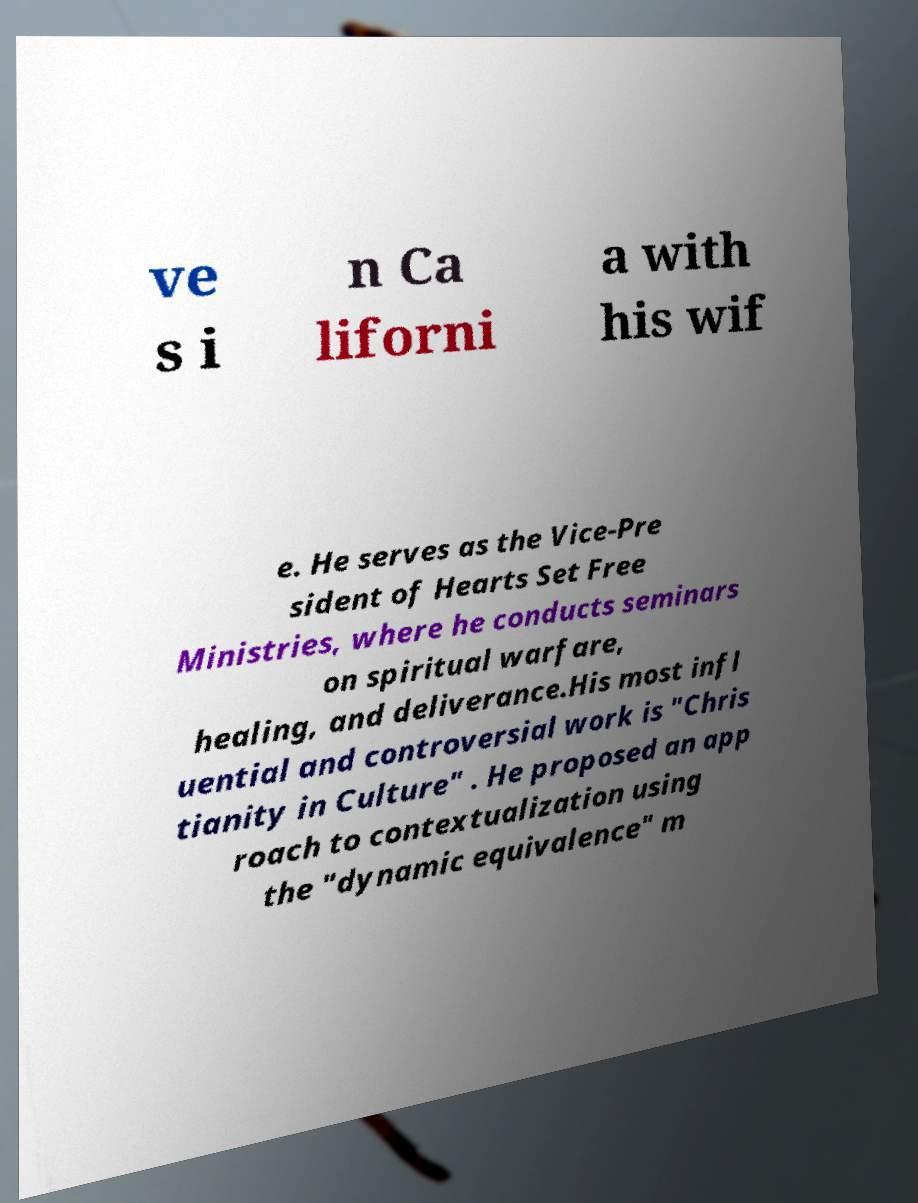Please identify and transcribe the text found in this image. ve s i n Ca liforni a with his wif e. He serves as the Vice-Pre sident of Hearts Set Free Ministries, where he conducts seminars on spiritual warfare, healing, and deliverance.His most infl uential and controversial work is "Chris tianity in Culture" . He proposed an app roach to contextualization using the "dynamic equivalence" m 